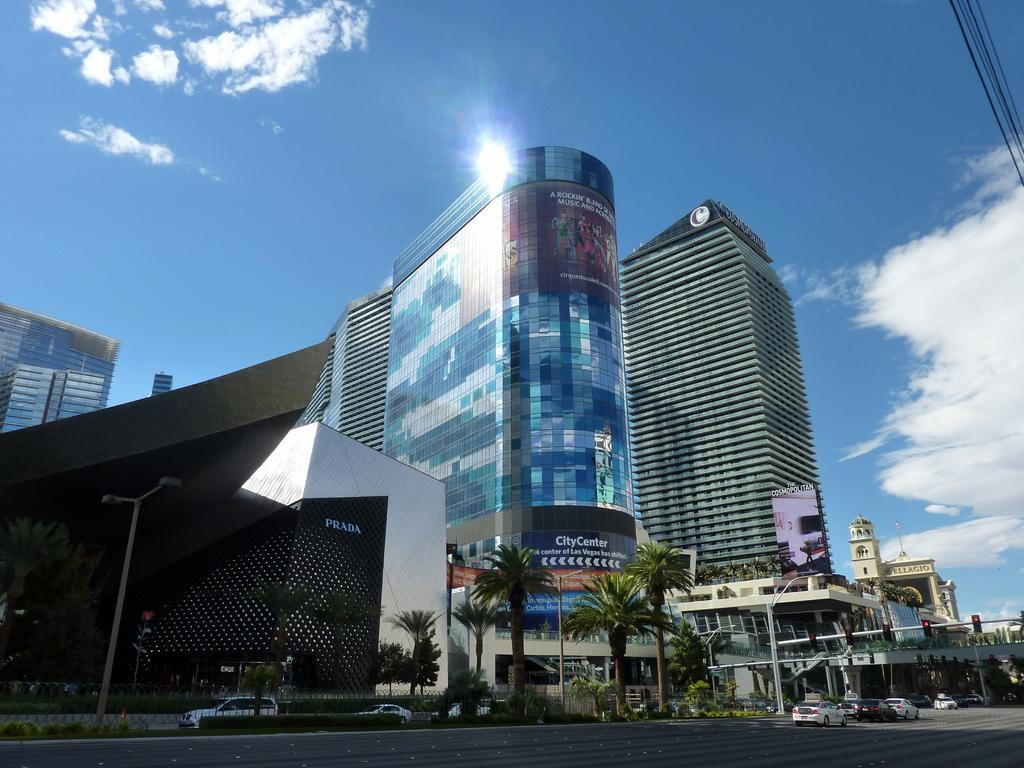Provide a one-sentence caption for the provided image. A few buildings with sunlight glinting off the top of the City Center. 